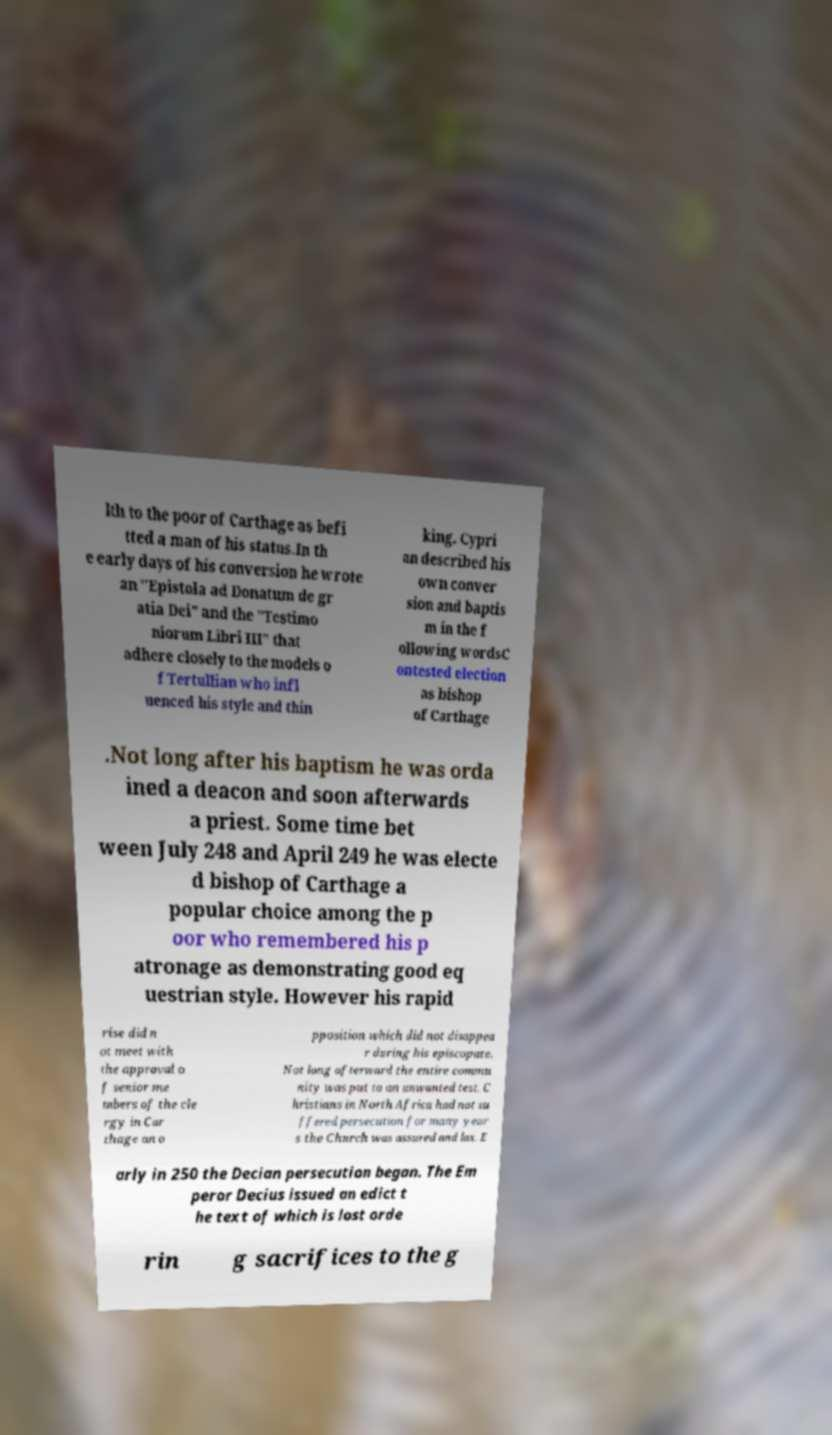Please read and relay the text visible in this image. What does it say? lth to the poor of Carthage as befi tted a man of his status.In th e early days of his conversion he wrote an "Epistola ad Donatum de gr atia Dei" and the "Testimo niorum Libri III" that adhere closely to the models o f Tertullian who infl uenced his style and thin king. Cypri an described his own conver sion and baptis m in the f ollowing wordsC ontested election as bishop of Carthage .Not long after his baptism he was orda ined a deacon and soon afterwards a priest. Some time bet ween July 248 and April 249 he was electe d bishop of Carthage a popular choice among the p oor who remembered his p atronage as demonstrating good eq uestrian style. However his rapid rise did n ot meet with the approval o f senior me mbers of the cle rgy in Car thage an o pposition which did not disappea r during his episcopate. Not long afterward the entire commu nity was put to an unwanted test. C hristians in North Africa had not su ffered persecution for many year s the Church was assured and lax. E arly in 250 the Decian persecution began. The Em peror Decius issued an edict t he text of which is lost orde rin g sacrifices to the g 